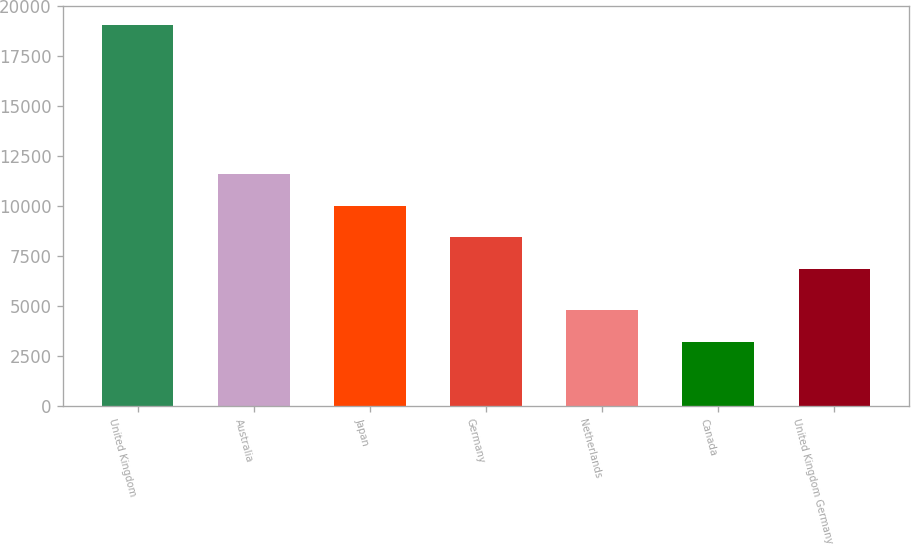<chart> <loc_0><loc_0><loc_500><loc_500><bar_chart><fcel>United Kingdom<fcel>Australia<fcel>Japan<fcel>Germany<fcel>Netherlands<fcel>Canada<fcel>United Kingdom Germany<nl><fcel>19079<fcel>11616.7<fcel>10031.8<fcel>8446.9<fcel>4814.9<fcel>3230<fcel>6862<nl></chart> 